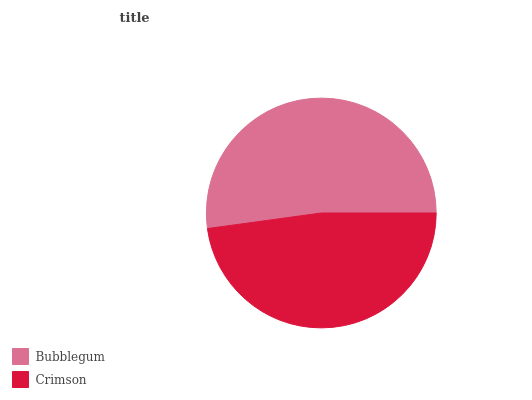Is Crimson the minimum?
Answer yes or no. Yes. Is Bubblegum the maximum?
Answer yes or no. Yes. Is Crimson the maximum?
Answer yes or no. No. Is Bubblegum greater than Crimson?
Answer yes or no. Yes. Is Crimson less than Bubblegum?
Answer yes or no. Yes. Is Crimson greater than Bubblegum?
Answer yes or no. No. Is Bubblegum less than Crimson?
Answer yes or no. No. Is Bubblegum the high median?
Answer yes or no. Yes. Is Crimson the low median?
Answer yes or no. Yes. Is Crimson the high median?
Answer yes or no. No. Is Bubblegum the low median?
Answer yes or no. No. 